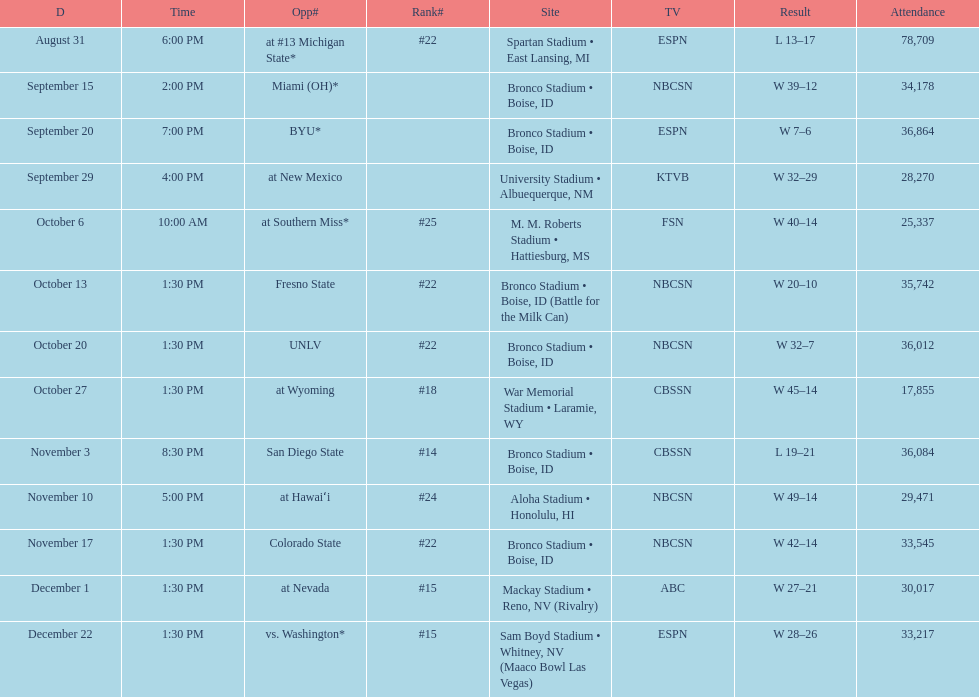Who were all of the opponents? At #13 michigan state*, miami (oh)*, byu*, at new mexico, at southern miss*, fresno state, unlv, at wyoming, san diego state, at hawaiʻi, colorado state, at nevada, vs. washington*. Who did they face on november 3rd? San Diego State. What rank were they on november 3rd? #14. 